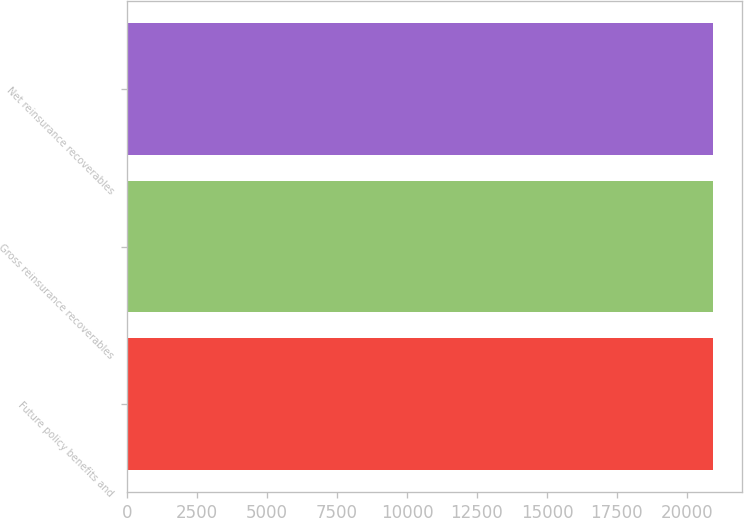<chart> <loc_0><loc_0><loc_500><loc_500><bar_chart><fcel>Future policy benefits and<fcel>Gross reinsurance recoverables<fcel>Net reinsurance recoverables<nl><fcel>20938<fcel>20938.1<fcel>20938.2<nl></chart> 